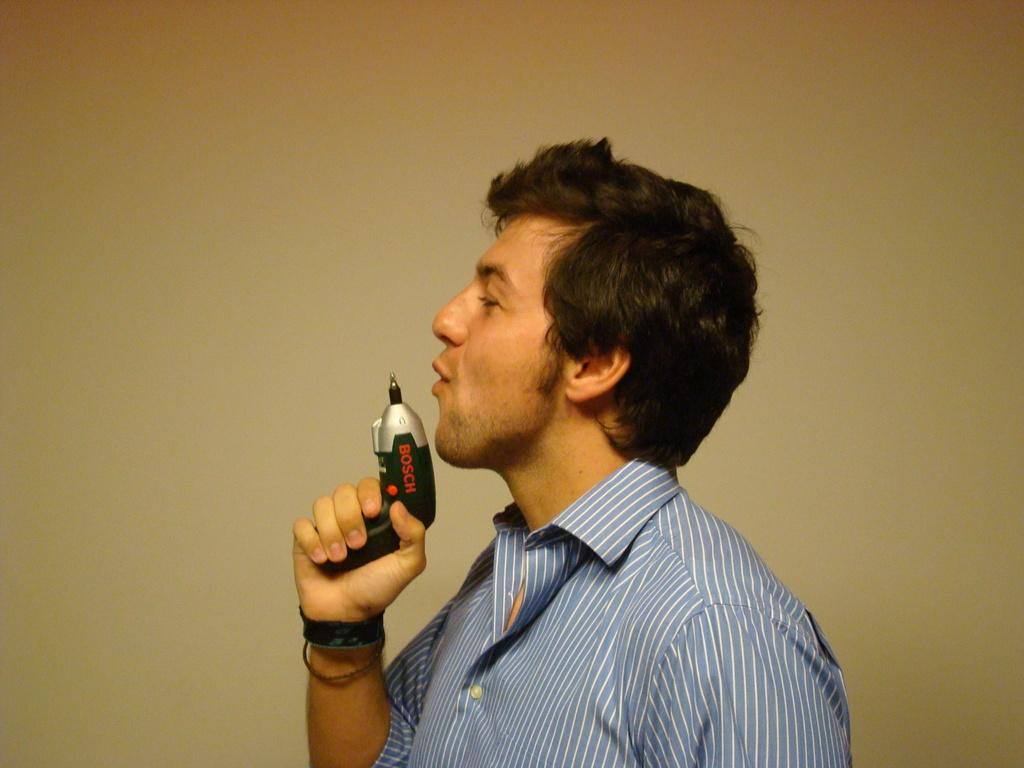Who is present in the image? There is a person in the image. What is the person wearing? The person is wearing a blue shirt. What is the person holding in their hand? The person is holding a black device in their hand. What can be seen in the background of the image? There is a wall in the background of the image. What color is the wall? The wall is yellow in color. How many lawyers are present in the image? There are no lawyers present in the image. Is there a group of people in the image? No, there is only one person in the image. Are there any balloons visible in the image? No, there are no balloons present in the image. 